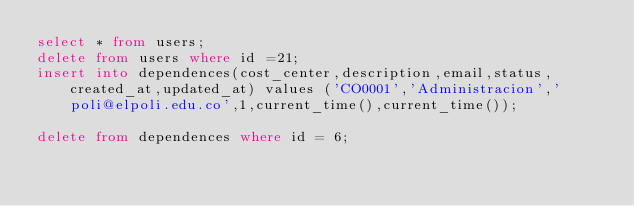Convert code to text. <code><loc_0><loc_0><loc_500><loc_500><_SQL_>select * from users;
delete from users where id =21;
insert into dependences(cost_center,description,email,status,created_at,updated_at) values ('CO0001','Administracion','poli@elpoli.edu.co',1,current_time(),current_time());

delete from dependences where id = 6;</code> 